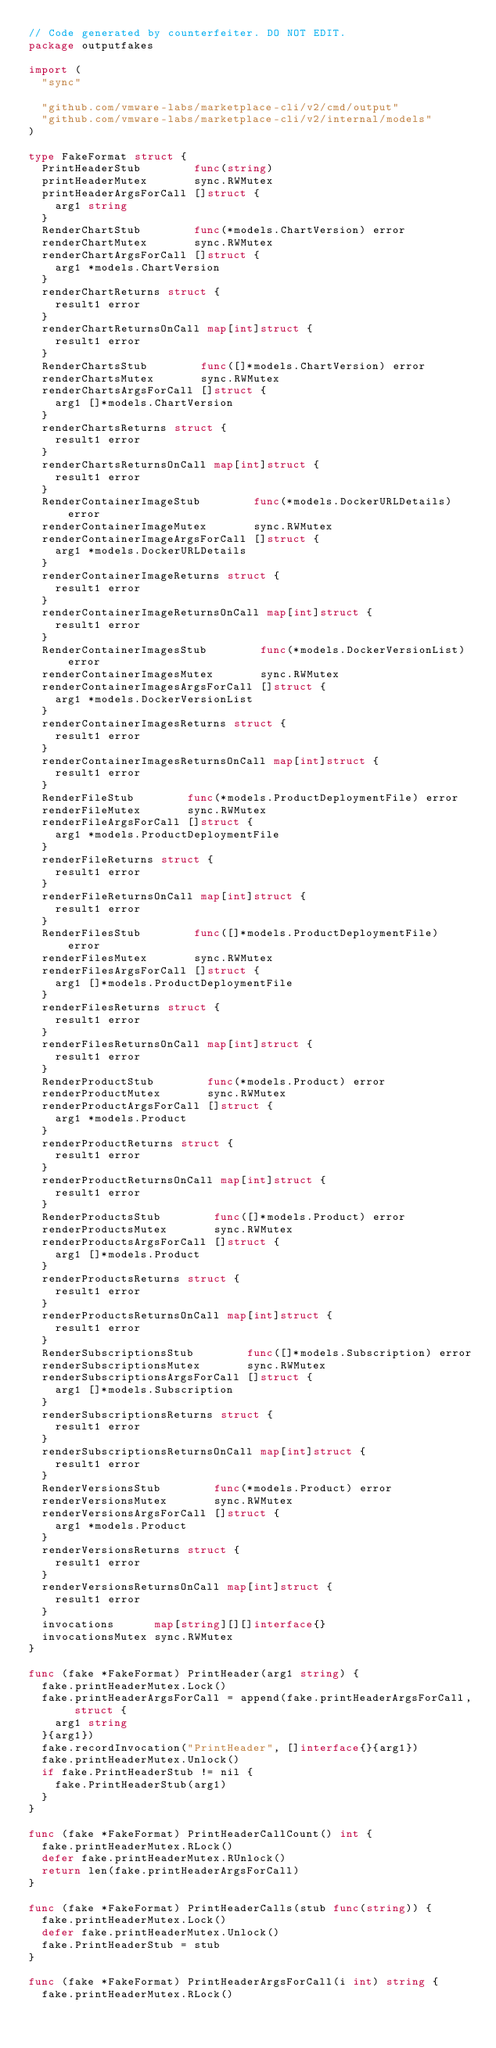Convert code to text. <code><loc_0><loc_0><loc_500><loc_500><_Go_>// Code generated by counterfeiter. DO NOT EDIT.
package outputfakes

import (
	"sync"

	"github.com/vmware-labs/marketplace-cli/v2/cmd/output"
	"github.com/vmware-labs/marketplace-cli/v2/internal/models"
)

type FakeFormat struct {
	PrintHeaderStub        func(string)
	printHeaderMutex       sync.RWMutex
	printHeaderArgsForCall []struct {
		arg1 string
	}
	RenderChartStub        func(*models.ChartVersion) error
	renderChartMutex       sync.RWMutex
	renderChartArgsForCall []struct {
		arg1 *models.ChartVersion
	}
	renderChartReturns struct {
		result1 error
	}
	renderChartReturnsOnCall map[int]struct {
		result1 error
	}
	RenderChartsStub        func([]*models.ChartVersion) error
	renderChartsMutex       sync.RWMutex
	renderChartsArgsForCall []struct {
		arg1 []*models.ChartVersion
	}
	renderChartsReturns struct {
		result1 error
	}
	renderChartsReturnsOnCall map[int]struct {
		result1 error
	}
	RenderContainerImageStub        func(*models.DockerURLDetails) error
	renderContainerImageMutex       sync.RWMutex
	renderContainerImageArgsForCall []struct {
		arg1 *models.DockerURLDetails
	}
	renderContainerImageReturns struct {
		result1 error
	}
	renderContainerImageReturnsOnCall map[int]struct {
		result1 error
	}
	RenderContainerImagesStub        func(*models.DockerVersionList) error
	renderContainerImagesMutex       sync.RWMutex
	renderContainerImagesArgsForCall []struct {
		arg1 *models.DockerVersionList
	}
	renderContainerImagesReturns struct {
		result1 error
	}
	renderContainerImagesReturnsOnCall map[int]struct {
		result1 error
	}
	RenderFileStub        func(*models.ProductDeploymentFile) error
	renderFileMutex       sync.RWMutex
	renderFileArgsForCall []struct {
		arg1 *models.ProductDeploymentFile
	}
	renderFileReturns struct {
		result1 error
	}
	renderFileReturnsOnCall map[int]struct {
		result1 error
	}
	RenderFilesStub        func([]*models.ProductDeploymentFile) error
	renderFilesMutex       sync.RWMutex
	renderFilesArgsForCall []struct {
		arg1 []*models.ProductDeploymentFile
	}
	renderFilesReturns struct {
		result1 error
	}
	renderFilesReturnsOnCall map[int]struct {
		result1 error
	}
	RenderProductStub        func(*models.Product) error
	renderProductMutex       sync.RWMutex
	renderProductArgsForCall []struct {
		arg1 *models.Product
	}
	renderProductReturns struct {
		result1 error
	}
	renderProductReturnsOnCall map[int]struct {
		result1 error
	}
	RenderProductsStub        func([]*models.Product) error
	renderProductsMutex       sync.RWMutex
	renderProductsArgsForCall []struct {
		arg1 []*models.Product
	}
	renderProductsReturns struct {
		result1 error
	}
	renderProductsReturnsOnCall map[int]struct {
		result1 error
	}
	RenderSubscriptionsStub        func([]*models.Subscription) error
	renderSubscriptionsMutex       sync.RWMutex
	renderSubscriptionsArgsForCall []struct {
		arg1 []*models.Subscription
	}
	renderSubscriptionsReturns struct {
		result1 error
	}
	renderSubscriptionsReturnsOnCall map[int]struct {
		result1 error
	}
	RenderVersionsStub        func(*models.Product) error
	renderVersionsMutex       sync.RWMutex
	renderVersionsArgsForCall []struct {
		arg1 *models.Product
	}
	renderVersionsReturns struct {
		result1 error
	}
	renderVersionsReturnsOnCall map[int]struct {
		result1 error
	}
	invocations      map[string][][]interface{}
	invocationsMutex sync.RWMutex
}

func (fake *FakeFormat) PrintHeader(arg1 string) {
	fake.printHeaderMutex.Lock()
	fake.printHeaderArgsForCall = append(fake.printHeaderArgsForCall, struct {
		arg1 string
	}{arg1})
	fake.recordInvocation("PrintHeader", []interface{}{arg1})
	fake.printHeaderMutex.Unlock()
	if fake.PrintHeaderStub != nil {
		fake.PrintHeaderStub(arg1)
	}
}

func (fake *FakeFormat) PrintHeaderCallCount() int {
	fake.printHeaderMutex.RLock()
	defer fake.printHeaderMutex.RUnlock()
	return len(fake.printHeaderArgsForCall)
}

func (fake *FakeFormat) PrintHeaderCalls(stub func(string)) {
	fake.printHeaderMutex.Lock()
	defer fake.printHeaderMutex.Unlock()
	fake.PrintHeaderStub = stub
}

func (fake *FakeFormat) PrintHeaderArgsForCall(i int) string {
	fake.printHeaderMutex.RLock()</code> 